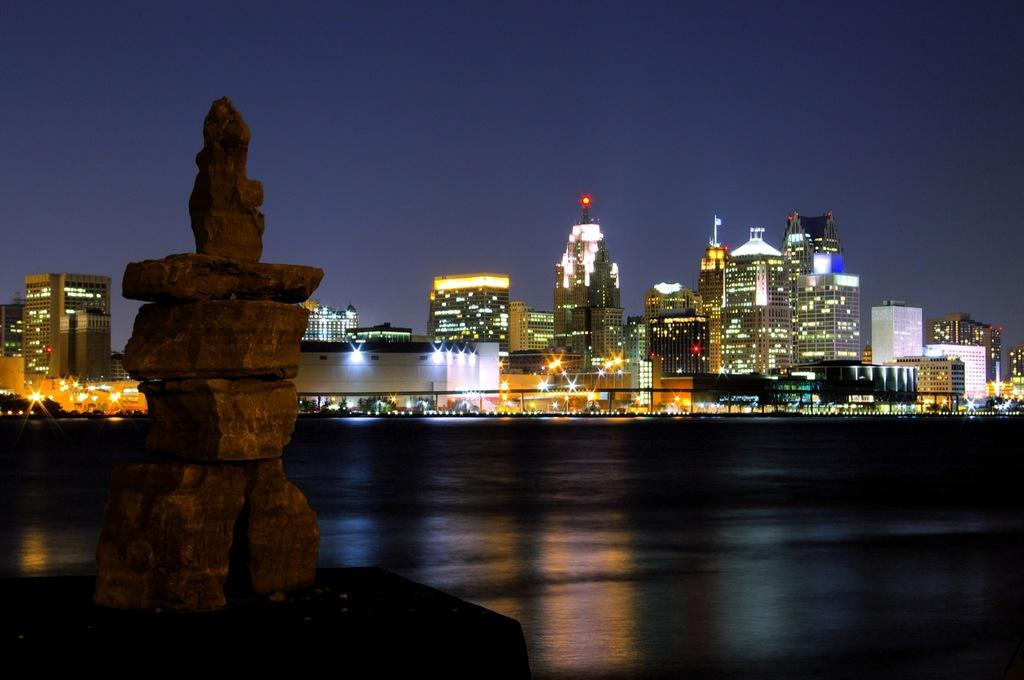What type of natural elements can be seen in the image? There are stones in the image. What is the surface on which the stones are placed? The ground is visible in the image. What can be seen in the distance in the image? There are buildings, lights, and the sky visible in the background of the image. Are there any other objects present in the background of the image? Yes, there are other objects in the background of the image. What is the average income of the pests in the image? There are no pests present in the image, so it is not possible to determine their average income. 